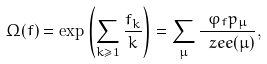Convert formula to latex. <formula><loc_0><loc_0><loc_500><loc_500>\Omega ( f ) = \exp \left ( \sum _ { k \geq 1 } \frac { f _ { k } } { k } \right ) = \sum _ { \mu } \frac { \varphi _ { f } p _ { \mu } } { \ z e e ( \mu ) } ,</formula> 